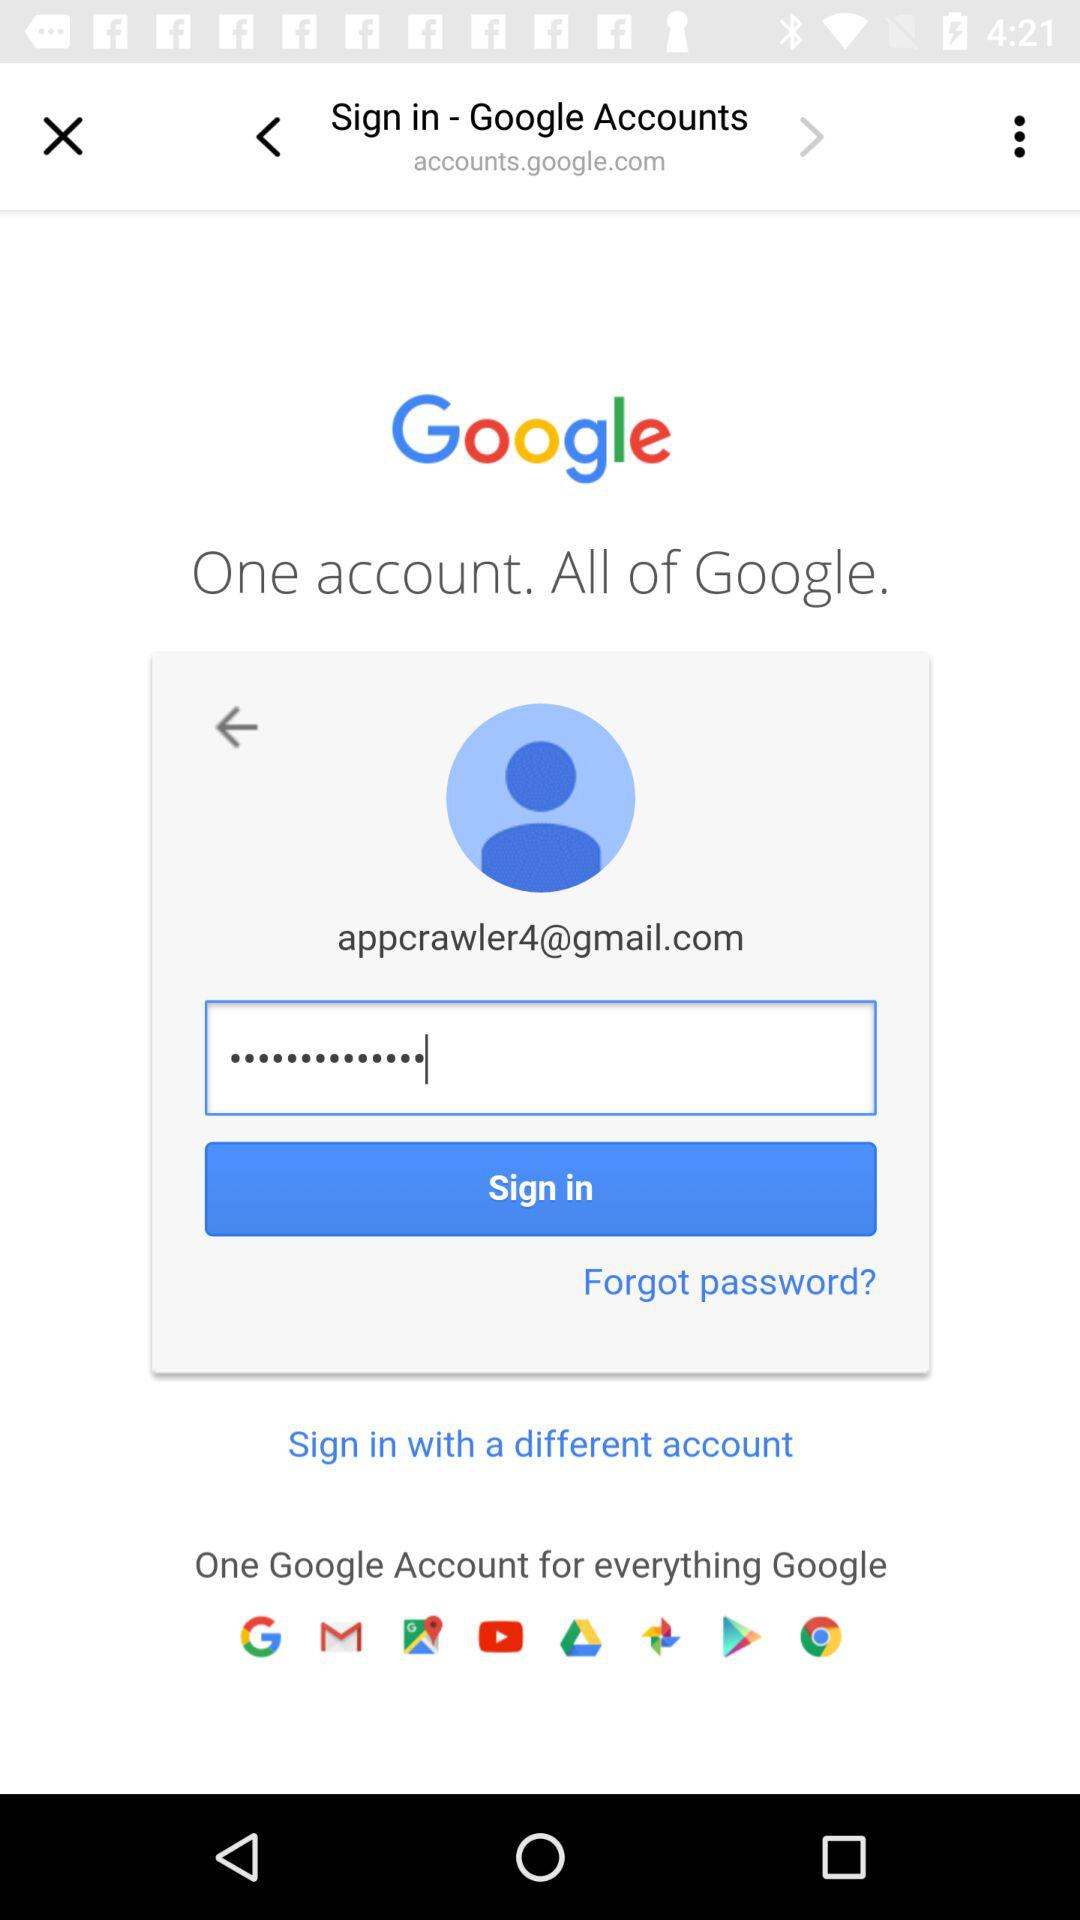When was the last login?
When the provided information is insufficient, respond with <no answer>. <no answer> 